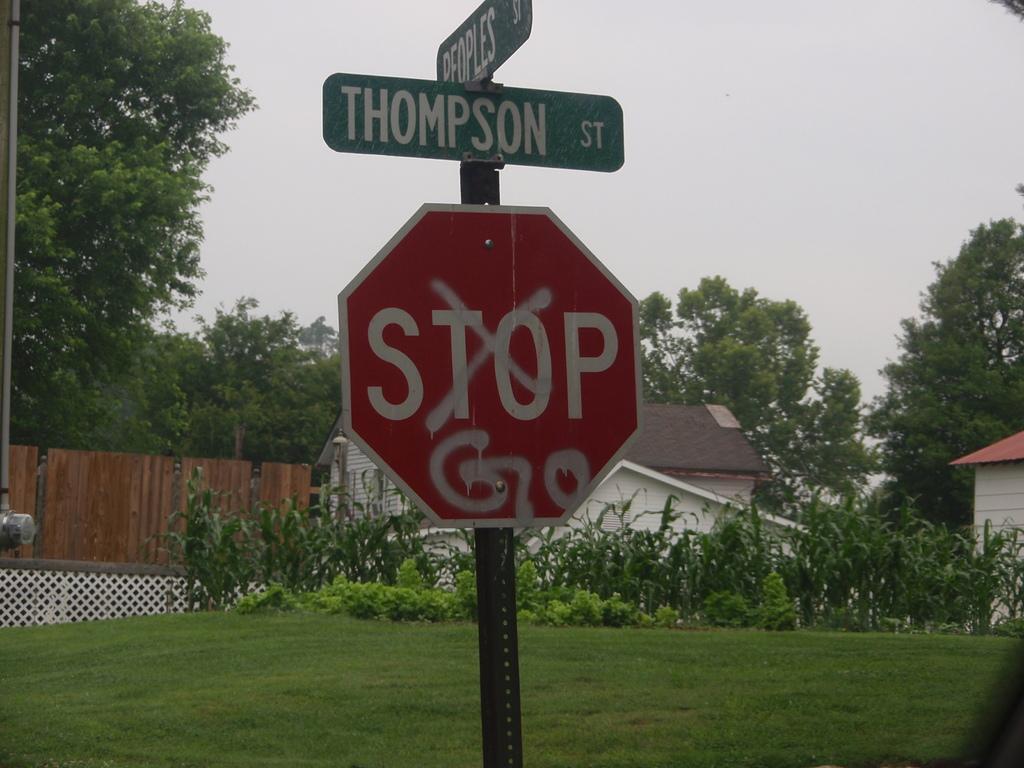In one or two sentences, can you explain what this image depicts? In this image I can see sign boards. They are in red and green color and something is written on it. Back Side I can see houses and trees. We can see a wooden fencing. The sky is in white color. 